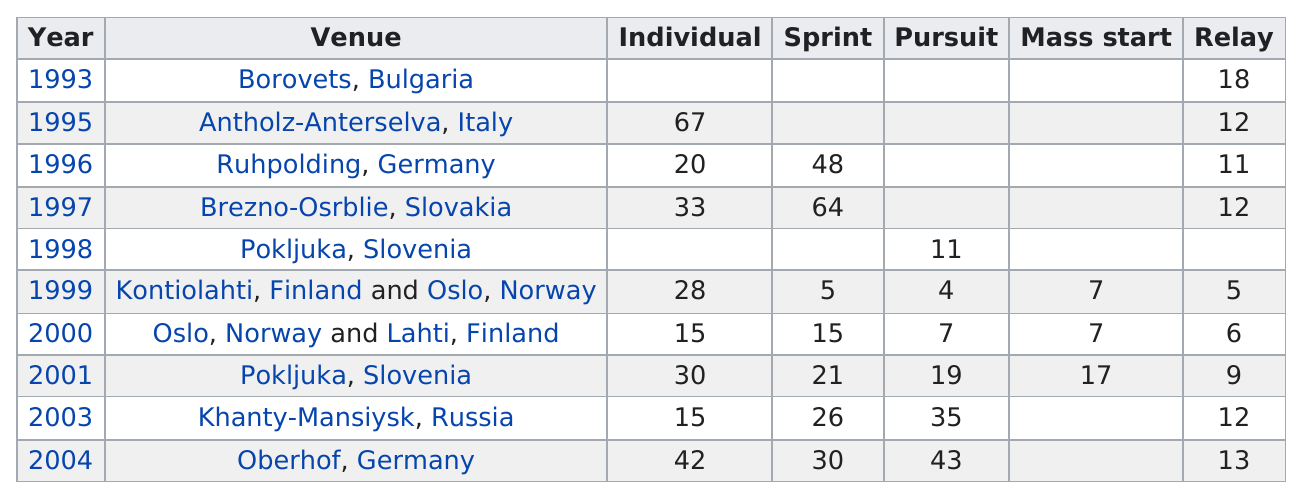Specify some key components in this picture. I will count the number of venues and give the total. The last championship took place in the year 2004. Antholz-Anterselva, Italy hosted the biathlon world championships in which the highest individual number of medals were won. 